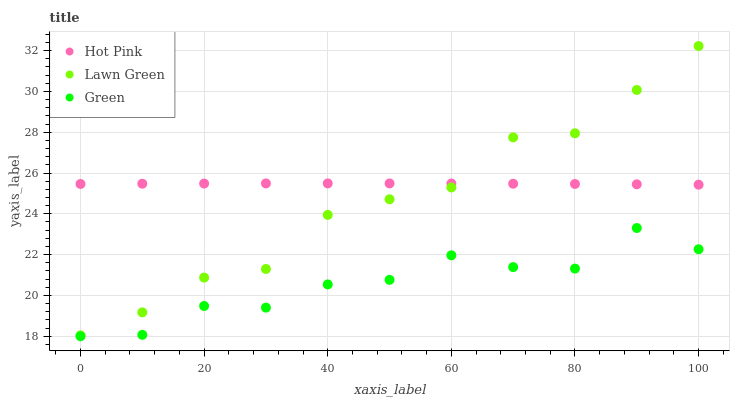Does Green have the minimum area under the curve?
Answer yes or no. Yes. Does Hot Pink have the maximum area under the curve?
Answer yes or no. Yes. Does Hot Pink have the minimum area under the curve?
Answer yes or no. No. Does Green have the maximum area under the curve?
Answer yes or no. No. Is Hot Pink the smoothest?
Answer yes or no. Yes. Is Green the roughest?
Answer yes or no. Yes. Is Green the smoothest?
Answer yes or no. No. Is Hot Pink the roughest?
Answer yes or no. No. Does Green have the lowest value?
Answer yes or no. Yes. Does Hot Pink have the lowest value?
Answer yes or no. No. Does Lawn Green have the highest value?
Answer yes or no. Yes. Does Hot Pink have the highest value?
Answer yes or no. No. Is Green less than Lawn Green?
Answer yes or no. Yes. Is Lawn Green greater than Green?
Answer yes or no. Yes. Does Lawn Green intersect Hot Pink?
Answer yes or no. Yes. Is Lawn Green less than Hot Pink?
Answer yes or no. No. Is Lawn Green greater than Hot Pink?
Answer yes or no. No. Does Green intersect Lawn Green?
Answer yes or no. No. 